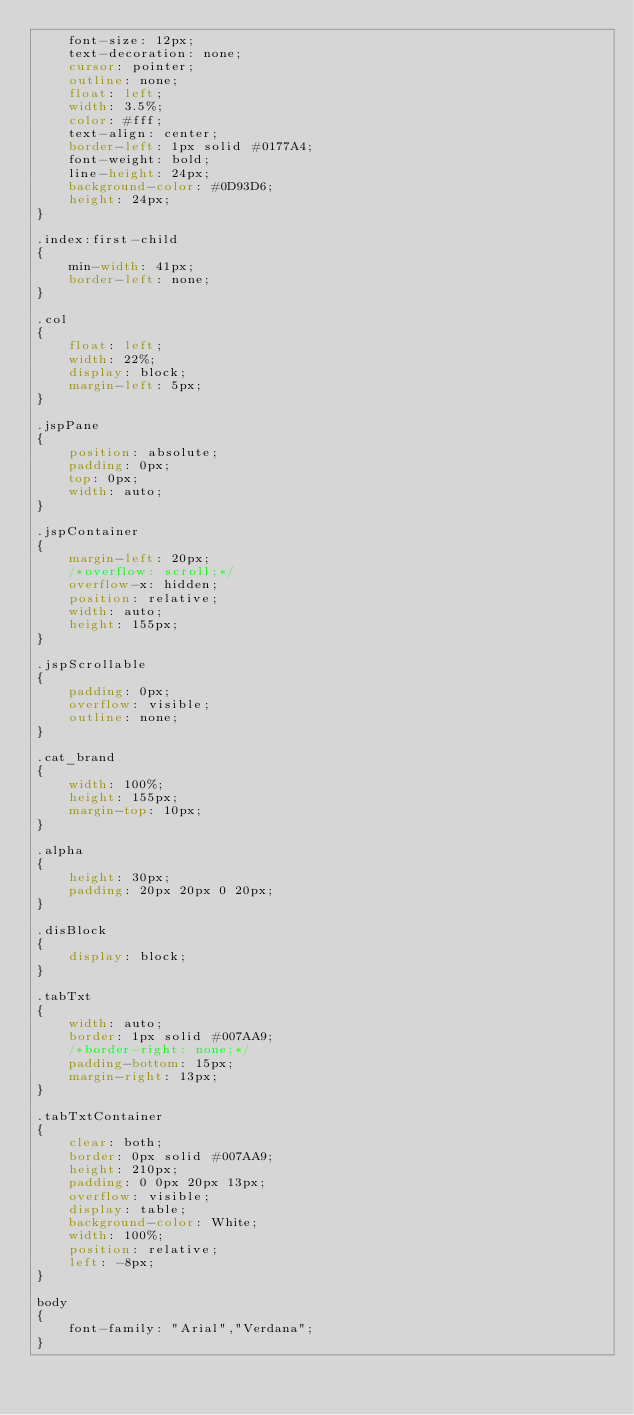<code> <loc_0><loc_0><loc_500><loc_500><_CSS_>    font-size: 12px;
    text-decoration: none;
    cursor: pointer;
    outline: none;
    float: left;
    width: 3.5%;
    color: #fff;
    text-align: center;
    border-left: 1px solid #0177A4;
    font-weight: bold;
    line-height: 24px;
    background-color: #0D93D6;
    height: 24px;
}

.index:first-child
{
    min-width: 41px;
    border-left: none;
}

.col
{
    float: left;
    width: 22%;
    display: block;
    margin-left: 5px;
}

.jspPane
{
    position: absolute;
    padding: 0px;
    top: 0px;
    width: auto;
}

.jspContainer
{
    margin-left: 20px;
    /*overflow: scroll;*/
    overflow-x: hidden;
    position: relative;
    width: auto;
    height: 155px;
}

.jspScrollable
{
    padding: 0px;
    overflow: visible;
    outline: none;
}

.cat_brand
{
    width: 100%;
    height: 155px;
    margin-top: 10px;
}

.alpha
{
    height: 30px;
    padding: 20px 20px 0 20px;
}

.disBlock
{
    display: block;
}

.tabTxt
{
    width: auto;
    border: 1px solid #007AA9;
    /*border-right: none;*/
    padding-bottom: 15px;
    margin-right: 13px;
}

.tabTxtContainer
{
    clear: both;
    border: 0px solid #007AA9;
    height: 210px;
    padding: 0 0px 20px 13px;
    overflow: visible;
    display: table;
    background-color: White;
    width: 100%;
    position: relative;
    left: -8px;
}

body
{
    font-family: "Arial","Verdana";
}
</code> 